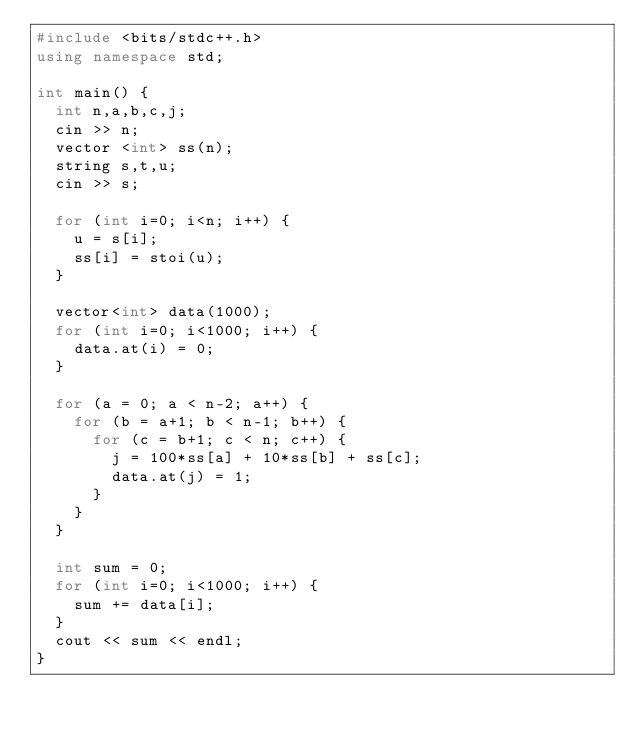Convert code to text. <code><loc_0><loc_0><loc_500><loc_500><_C++_>#include <bits/stdc++.h>
using namespace std;
 
int main() {
  int n,a,b,c,j;
  cin >> n;
  vector <int> ss(n);
  string s,t,u;
  cin >> s;
  
  for (int i=0; i<n; i++) {
    u = s[i];
    ss[i] = stoi(u);
  }
  
  vector<int> data(1000);
  for (int i=0; i<1000; i++) {
    data.at(i) = 0;
  }
  
  for (a = 0; a < n-2; a++) {
    for (b = a+1; b < n-1; b++) {
      for (c = b+1; c < n; c++) {
        j = 100*ss[a] + 10*ss[b] + ss[c];
        data.at(j) = 1;
      }
    }
  }

  int sum = 0;
  for (int i=0; i<1000; i++) {
    sum += data[i];
  }
  cout << sum << endl;  
}
</code> 